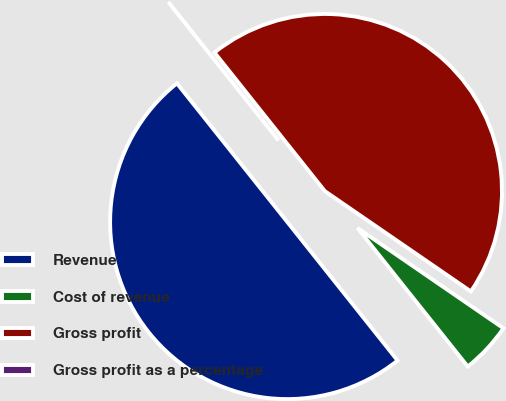<chart> <loc_0><loc_0><loc_500><loc_500><pie_chart><fcel>Revenue<fcel>Cost of revenue<fcel>Gross profit<fcel>Gross profit as a percentage<nl><fcel>50.0%<fcel>4.72%<fcel>45.28%<fcel>0.0%<nl></chart> 